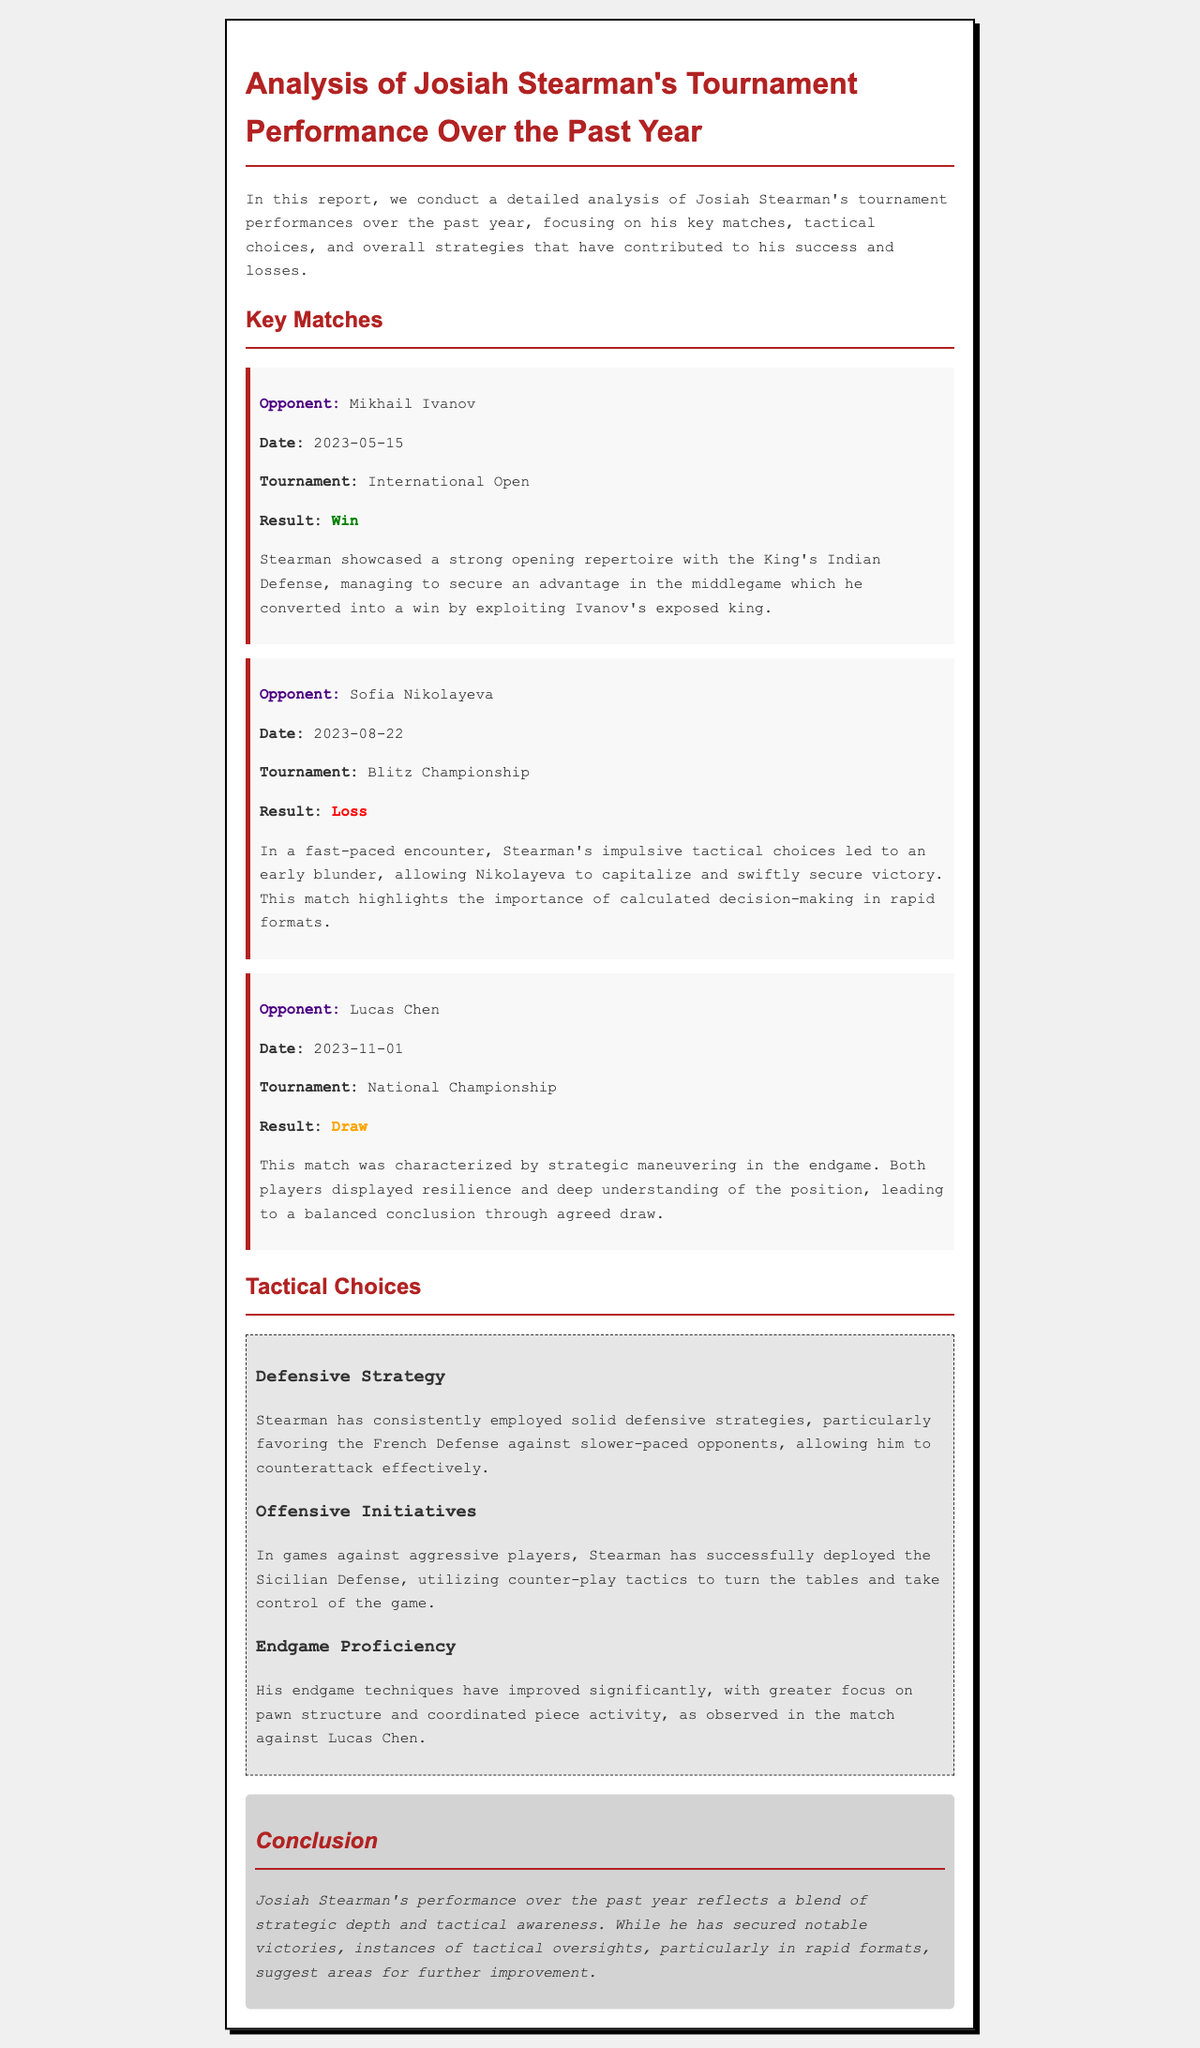What was the date of Josiah Stearman's match against Mikhail Ivanov? The date of the match against Mikhail Ivanov is explicitly mentioned in the document as May 15, 2023.
Answer: May 15, 2023 What is the result of Josiah Stearman's game against Sofia Nikolayeva? The result of the game against Sofia Nikolayeva is indicated in the report as a loss.
Answer: Loss Which opening did Stearman use in his match against Ivanov? The document specifies that Stearman employed the King's Indian Defense in his match against Ivanov.
Answer: King's Indian Defense What tactical mistake did Stearman make during the Blitz Championship? The report states that Stearman's impulsive tactical choices led to an early blunder.
Answer: Early blunder What has improved in Josiah Stearman’s performance over the past year? The document notes that his endgame techniques have improved significantly.
Answer: Endgame techniques In which tournament did Stearman draw with Lucas Chen? The document clearly states that the match with Lucas Chen ended in a draw at the National Championship.
Answer: National Championship What defensive strategy does Stearman favor against slower-paced opponents? The report mentions that Stearman consistently employs the French Defense against slower-paced opponents.
Answer: French Defense What does the conclusion say about Stearman’s performance? The conclusion states that Stearman's performance reflects a blend of strategic depth and tactical awareness.
Answer: Strategic depth and tactical awareness What color indicates a win in the document? The color that indicates a win in the match results is green.
Answer: Green 